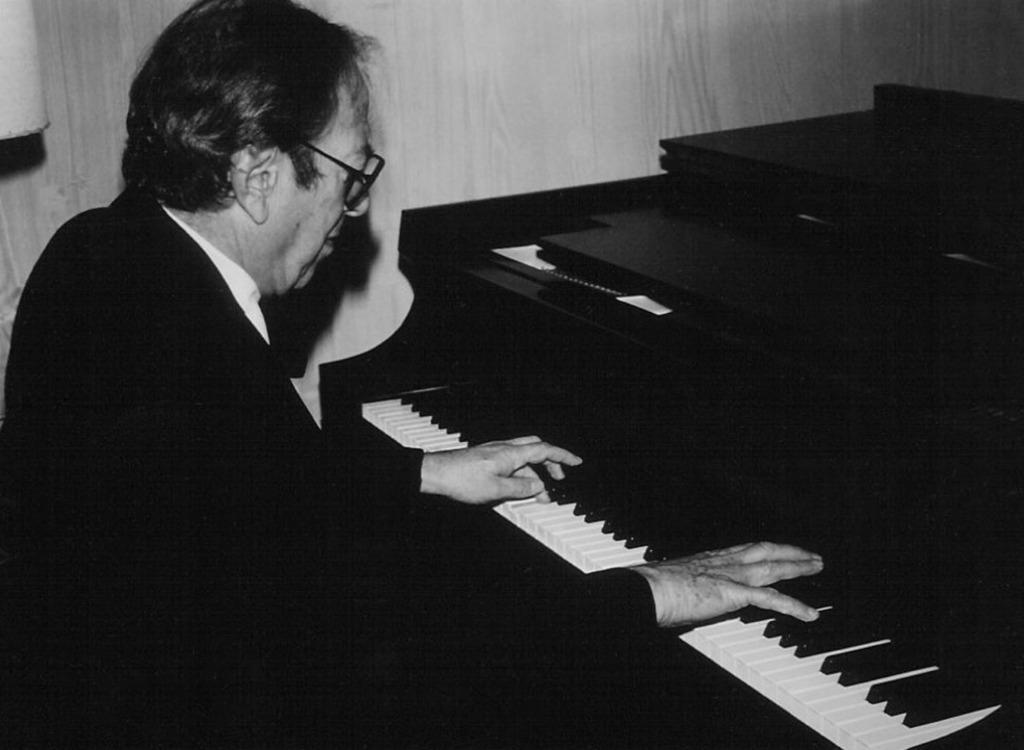What is the main subject of the image? The main subject of the image is a man. What is the man doing in the image? The man is playing a musical instrument in the image. What type of drink is the man holding while playing the musical instrument? There is no drink visible in the image; the man is only playing a musical instrument. 